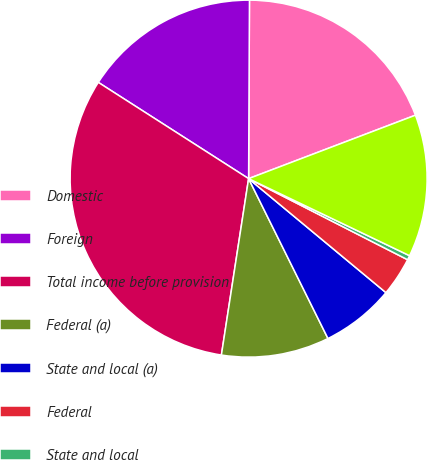<chart> <loc_0><loc_0><loc_500><loc_500><pie_chart><fcel>Domestic<fcel>Foreign<fcel>Total income before provision<fcel>Federal (a)<fcel>State and local (a)<fcel>Federal<fcel>State and local<fcel>Total provision for income<nl><fcel>19.14%<fcel>16.01%<fcel>31.63%<fcel>9.77%<fcel>6.64%<fcel>3.52%<fcel>0.4%<fcel>12.89%<nl></chart> 